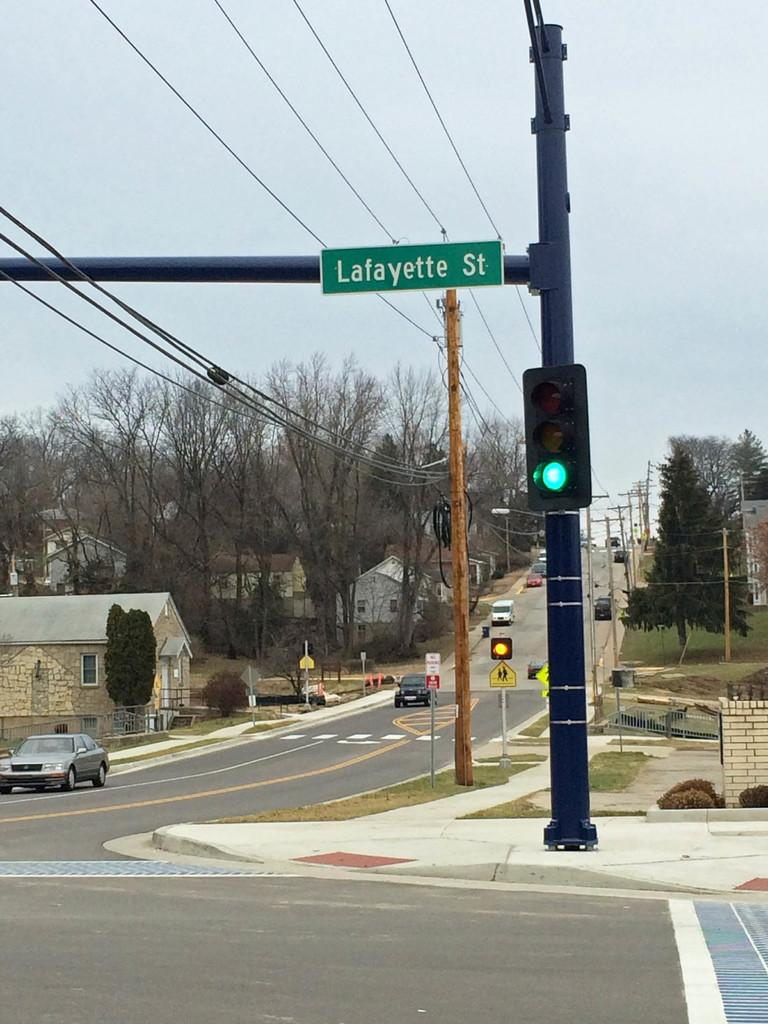Provide a one-sentence caption for the provided image. A street corner with a green light at Lafayette St. 